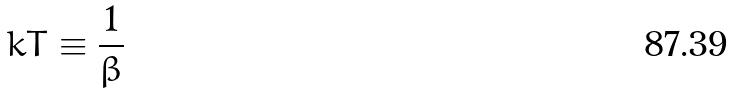Convert formula to latex. <formula><loc_0><loc_0><loc_500><loc_500>k T \equiv \frac { 1 } { \beta }</formula> 